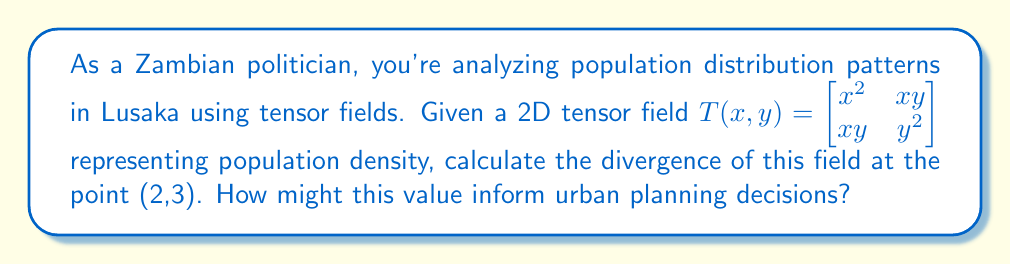Help me with this question. To solve this problem, we'll follow these steps:

1) The divergence of a 2D tensor field $T(x,y) = \begin{bmatrix} T_{11} & T_{12} \\ T_{21} & T_{22} \end{bmatrix}$ is given by:

   $\text{div}(T) = \frac{\partial T_{11}}{\partial x} + \frac{\partial T_{22}}{\partial y}$

2) In our case, $T_{11} = x^2$ and $T_{22} = y^2$

3) Calculate $\frac{\partial T_{11}}{\partial x}$:
   $\frac{\partial T_{11}}{\partial x} = \frac{\partial (x^2)}{\partial x} = 2x$

4) Calculate $\frac{\partial T_{22}}{\partial y}$:
   $\frac{\partial T_{22}}{\partial y} = \frac{\partial (y^2)}{\partial y} = 2y$

5) Sum these partial derivatives:
   $\text{div}(T) = 2x + 2y$

6) Evaluate at the point (2,3):
   $\text{div}(T)|_{(2,3)} = 2(2) + 2(3) = 4 + 6 = 10$

This positive divergence indicates a net outflow of population from the point (2,3), which could inform urban planning decisions such as the need for improved infrastructure or public services in this area to retain population.
Answer: 10 